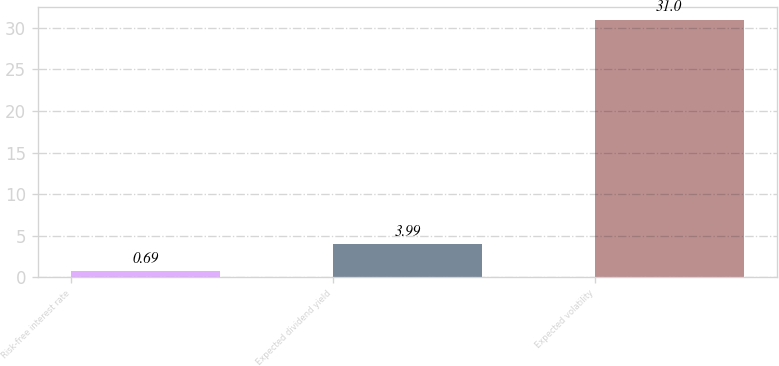<chart> <loc_0><loc_0><loc_500><loc_500><bar_chart><fcel>Risk-free interest rate<fcel>Expected dividend yield<fcel>Expected volatility<nl><fcel>0.69<fcel>3.99<fcel>31<nl></chart> 